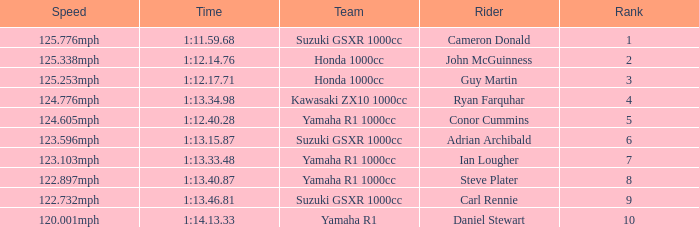What is the rank for the team with a Time of 1:12.40.28? 5.0. 